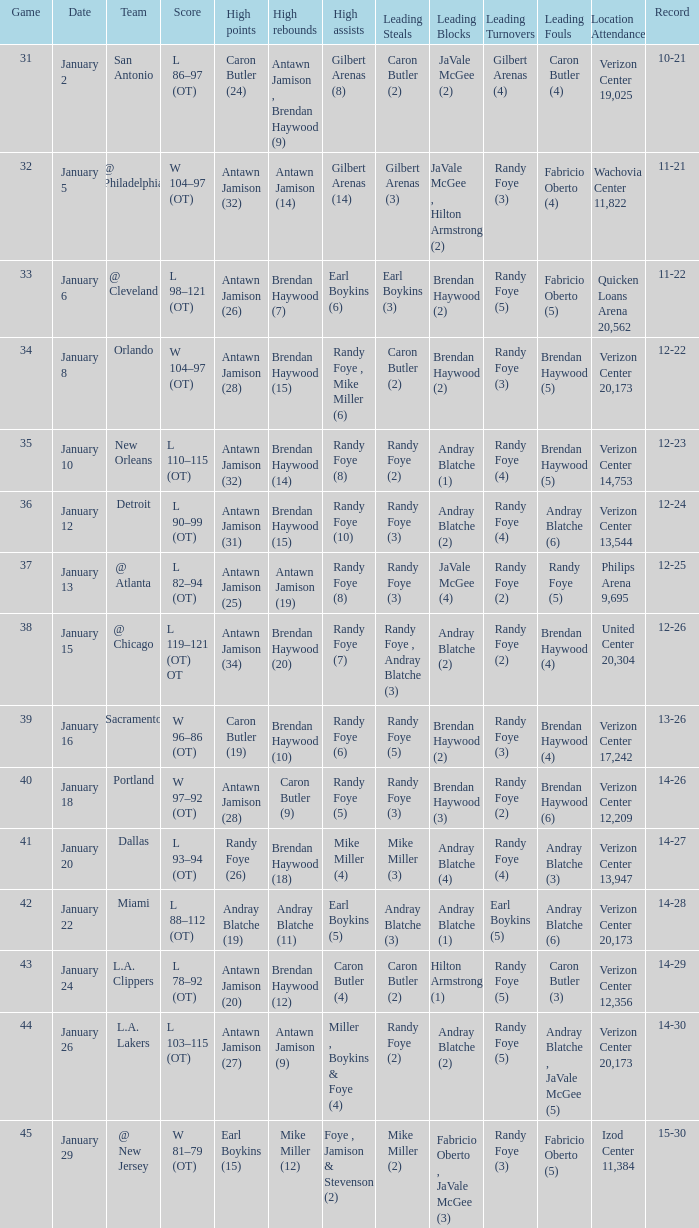Who had the highest points on January 2? Caron Butler (24). 